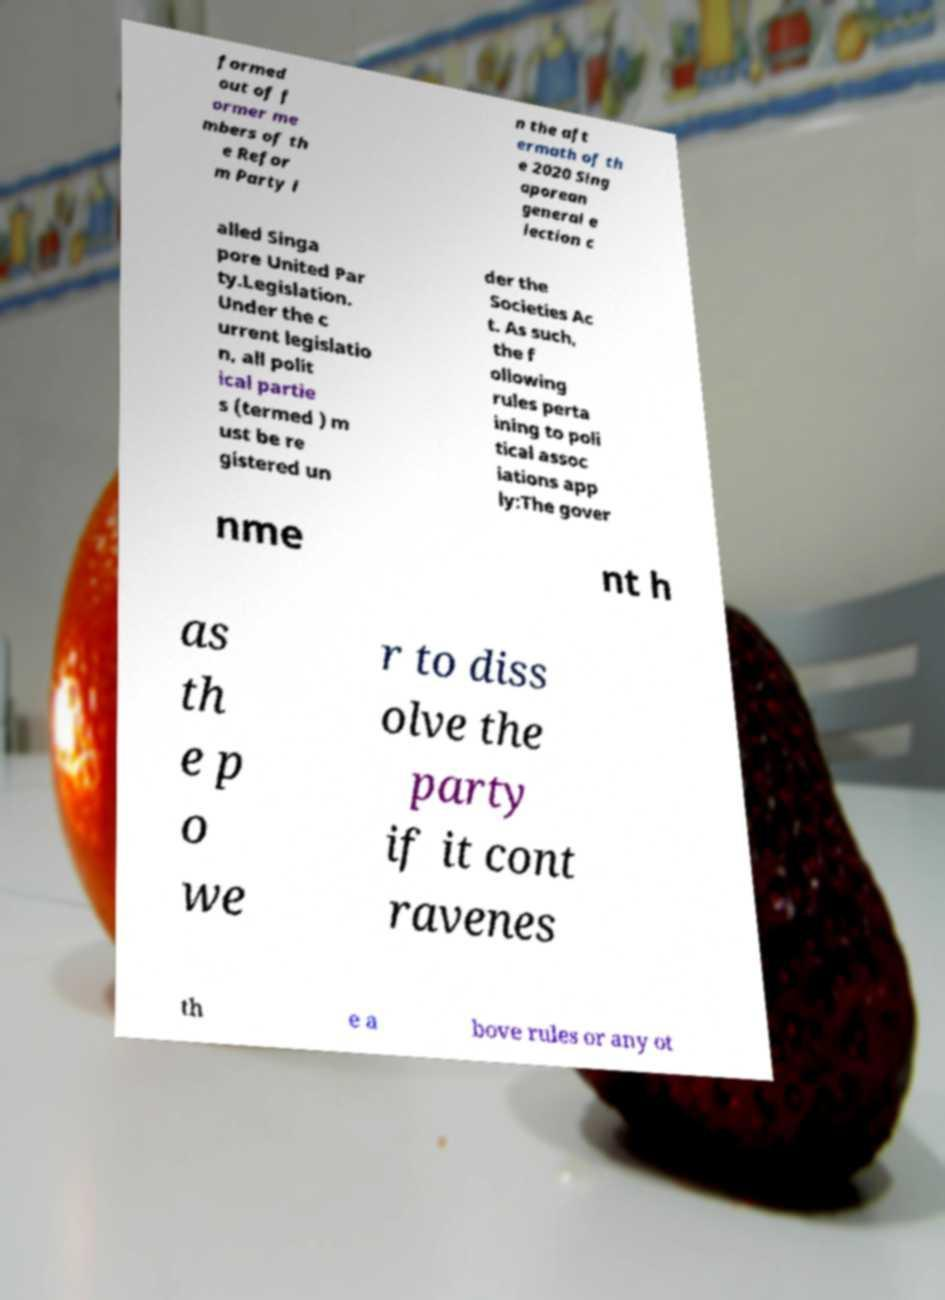Please read and relay the text visible in this image. What does it say? formed out of f ormer me mbers of th e Refor m Party i n the aft ermath of th e 2020 Sing aporean general e lection c alled Singa pore United Par ty.Legislation. Under the c urrent legislatio n, all polit ical partie s (termed ) m ust be re gistered un der the Societies Ac t. As such, the f ollowing rules perta ining to poli tical assoc iations app ly:The gover nme nt h as th e p o we r to diss olve the party if it cont ravenes th e a bove rules or any ot 